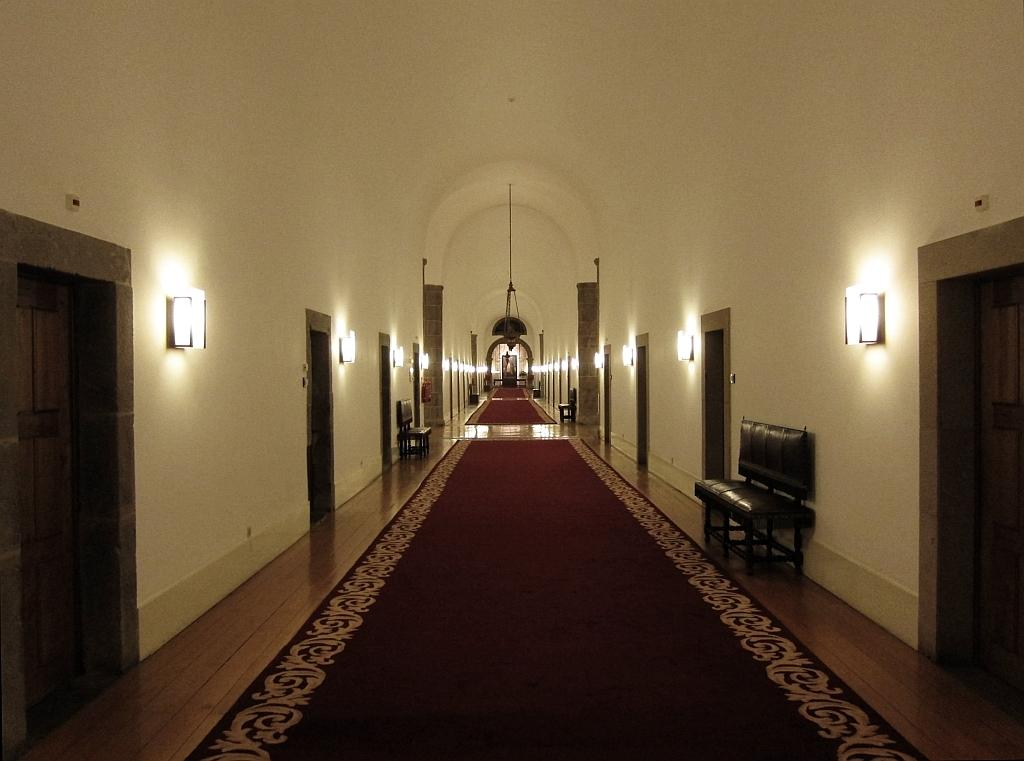What can be seen in the foreground area of the image? In the foreground area of the image, there are doors and a rug on the floor. What is visible in the background of the image? In the background of the image, there are doors, sofas, lamps, a chandelier, and an arch. Can you describe the flooring in the foreground area of the image? The flooring in the foreground area of the image is covered by a rug. What type of lighting fixtures are present in the background of the image? There are lamps and a chandelier present in the background of the image. What is the rate of the partner's performance in the image? There is no partner or performance mentioned in the image; it features doors, rugs, sofas, lamps, a chandelier, and an arch. Can you tell me the street name where the image was taken? The provided facts do not mention any street names or locations, so it cannot be determined from the image. 